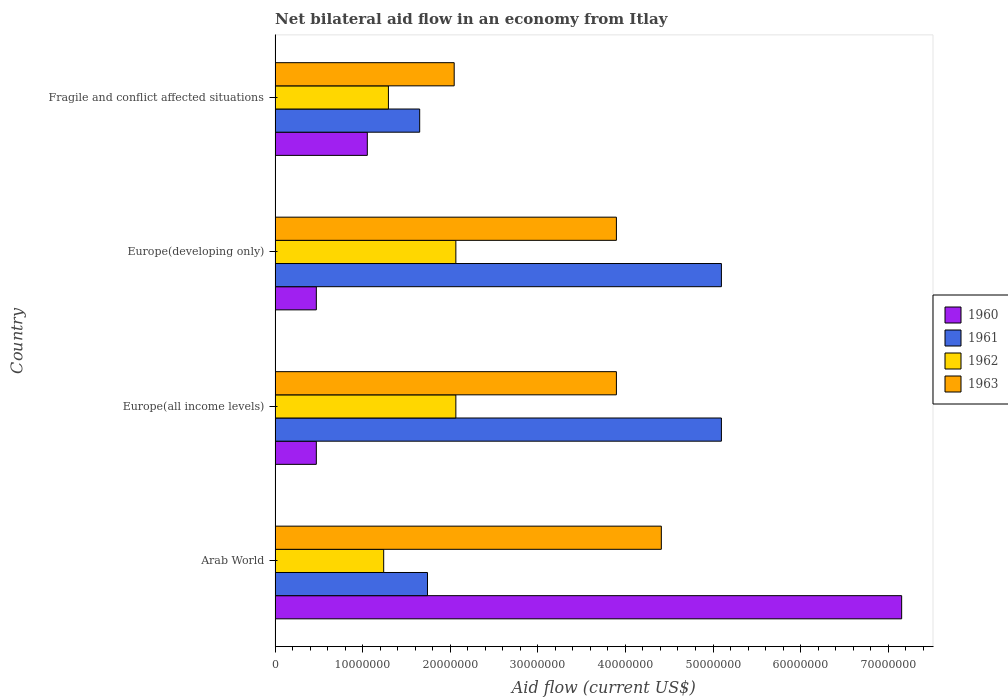How many bars are there on the 2nd tick from the top?
Your answer should be very brief. 4. What is the label of the 2nd group of bars from the top?
Provide a short and direct response. Europe(developing only). What is the net bilateral aid flow in 1963 in Arab World?
Give a very brief answer. 4.41e+07. Across all countries, what is the maximum net bilateral aid flow in 1961?
Your answer should be compact. 5.10e+07. Across all countries, what is the minimum net bilateral aid flow in 1962?
Offer a very short reply. 1.24e+07. In which country was the net bilateral aid flow in 1961 maximum?
Offer a terse response. Europe(all income levels). In which country was the net bilateral aid flow in 1962 minimum?
Offer a very short reply. Arab World. What is the total net bilateral aid flow in 1960 in the graph?
Your answer should be very brief. 9.15e+07. What is the difference between the net bilateral aid flow in 1962 in Arab World and that in Fragile and conflict affected situations?
Your answer should be compact. -5.40e+05. What is the difference between the net bilateral aid flow in 1960 in Arab World and the net bilateral aid flow in 1963 in Europe(all income levels)?
Your response must be concise. 3.26e+07. What is the average net bilateral aid flow in 1963 per country?
Your answer should be very brief. 3.56e+07. What is the difference between the net bilateral aid flow in 1962 and net bilateral aid flow in 1960 in Fragile and conflict affected situations?
Offer a very short reply. 2.41e+06. What is the ratio of the net bilateral aid flow in 1960 in Europe(developing only) to that in Fragile and conflict affected situations?
Your answer should be compact. 0.45. Is the net bilateral aid flow in 1961 in Arab World less than that in Europe(all income levels)?
Make the answer very short. Yes. What is the difference between the highest and the second highest net bilateral aid flow in 1960?
Keep it short and to the point. 6.10e+07. What is the difference between the highest and the lowest net bilateral aid flow in 1962?
Provide a short and direct response. 8.24e+06. In how many countries, is the net bilateral aid flow in 1961 greater than the average net bilateral aid flow in 1961 taken over all countries?
Ensure brevity in your answer.  2. What does the 4th bar from the top in Fragile and conflict affected situations represents?
Your answer should be compact. 1960. Are all the bars in the graph horizontal?
Keep it short and to the point. Yes. What is the difference between two consecutive major ticks on the X-axis?
Your response must be concise. 1.00e+07. Are the values on the major ticks of X-axis written in scientific E-notation?
Your response must be concise. No. Does the graph contain grids?
Your answer should be compact. No. Where does the legend appear in the graph?
Make the answer very short. Center right. How are the legend labels stacked?
Provide a succinct answer. Vertical. What is the title of the graph?
Give a very brief answer. Net bilateral aid flow in an economy from Itlay. Does "1995" appear as one of the legend labels in the graph?
Your answer should be very brief. No. What is the label or title of the Y-axis?
Your response must be concise. Country. What is the Aid flow (current US$) of 1960 in Arab World?
Your answer should be very brief. 7.15e+07. What is the Aid flow (current US$) in 1961 in Arab World?
Offer a very short reply. 1.74e+07. What is the Aid flow (current US$) in 1962 in Arab World?
Your answer should be very brief. 1.24e+07. What is the Aid flow (current US$) of 1963 in Arab World?
Offer a terse response. 4.41e+07. What is the Aid flow (current US$) in 1960 in Europe(all income levels)?
Offer a terse response. 4.71e+06. What is the Aid flow (current US$) of 1961 in Europe(all income levels)?
Make the answer very short. 5.10e+07. What is the Aid flow (current US$) of 1962 in Europe(all income levels)?
Your answer should be compact. 2.06e+07. What is the Aid flow (current US$) of 1963 in Europe(all income levels)?
Offer a very short reply. 3.90e+07. What is the Aid flow (current US$) of 1960 in Europe(developing only)?
Keep it short and to the point. 4.71e+06. What is the Aid flow (current US$) of 1961 in Europe(developing only)?
Keep it short and to the point. 5.10e+07. What is the Aid flow (current US$) in 1962 in Europe(developing only)?
Make the answer very short. 2.06e+07. What is the Aid flow (current US$) in 1963 in Europe(developing only)?
Make the answer very short. 3.90e+07. What is the Aid flow (current US$) of 1960 in Fragile and conflict affected situations?
Ensure brevity in your answer.  1.05e+07. What is the Aid flow (current US$) of 1961 in Fragile and conflict affected situations?
Give a very brief answer. 1.65e+07. What is the Aid flow (current US$) in 1962 in Fragile and conflict affected situations?
Offer a terse response. 1.29e+07. What is the Aid flow (current US$) in 1963 in Fragile and conflict affected situations?
Your answer should be compact. 2.04e+07. Across all countries, what is the maximum Aid flow (current US$) of 1960?
Your response must be concise. 7.15e+07. Across all countries, what is the maximum Aid flow (current US$) in 1961?
Provide a short and direct response. 5.10e+07. Across all countries, what is the maximum Aid flow (current US$) in 1962?
Ensure brevity in your answer.  2.06e+07. Across all countries, what is the maximum Aid flow (current US$) in 1963?
Your answer should be compact. 4.41e+07. Across all countries, what is the minimum Aid flow (current US$) in 1960?
Provide a short and direct response. 4.71e+06. Across all countries, what is the minimum Aid flow (current US$) of 1961?
Give a very brief answer. 1.65e+07. Across all countries, what is the minimum Aid flow (current US$) in 1962?
Offer a terse response. 1.24e+07. Across all countries, what is the minimum Aid flow (current US$) of 1963?
Give a very brief answer. 2.04e+07. What is the total Aid flow (current US$) in 1960 in the graph?
Provide a short and direct response. 9.15e+07. What is the total Aid flow (current US$) of 1961 in the graph?
Give a very brief answer. 1.36e+08. What is the total Aid flow (current US$) of 1962 in the graph?
Make the answer very short. 6.66e+07. What is the total Aid flow (current US$) of 1963 in the graph?
Keep it short and to the point. 1.42e+08. What is the difference between the Aid flow (current US$) in 1960 in Arab World and that in Europe(all income levels)?
Your answer should be compact. 6.68e+07. What is the difference between the Aid flow (current US$) of 1961 in Arab World and that in Europe(all income levels)?
Keep it short and to the point. -3.36e+07. What is the difference between the Aid flow (current US$) in 1962 in Arab World and that in Europe(all income levels)?
Keep it short and to the point. -8.24e+06. What is the difference between the Aid flow (current US$) of 1963 in Arab World and that in Europe(all income levels)?
Keep it short and to the point. 5.13e+06. What is the difference between the Aid flow (current US$) of 1960 in Arab World and that in Europe(developing only)?
Keep it short and to the point. 6.68e+07. What is the difference between the Aid flow (current US$) in 1961 in Arab World and that in Europe(developing only)?
Provide a succinct answer. -3.36e+07. What is the difference between the Aid flow (current US$) of 1962 in Arab World and that in Europe(developing only)?
Your answer should be very brief. -8.24e+06. What is the difference between the Aid flow (current US$) in 1963 in Arab World and that in Europe(developing only)?
Offer a terse response. 5.13e+06. What is the difference between the Aid flow (current US$) of 1960 in Arab World and that in Fragile and conflict affected situations?
Offer a terse response. 6.10e+07. What is the difference between the Aid flow (current US$) in 1961 in Arab World and that in Fragile and conflict affected situations?
Your answer should be very brief. 8.90e+05. What is the difference between the Aid flow (current US$) of 1962 in Arab World and that in Fragile and conflict affected situations?
Ensure brevity in your answer.  -5.40e+05. What is the difference between the Aid flow (current US$) of 1963 in Arab World and that in Fragile and conflict affected situations?
Your response must be concise. 2.36e+07. What is the difference between the Aid flow (current US$) in 1960 in Europe(all income levels) and that in Europe(developing only)?
Offer a terse response. 0. What is the difference between the Aid flow (current US$) of 1961 in Europe(all income levels) and that in Europe(developing only)?
Keep it short and to the point. 0. What is the difference between the Aid flow (current US$) of 1962 in Europe(all income levels) and that in Europe(developing only)?
Keep it short and to the point. 0. What is the difference between the Aid flow (current US$) of 1963 in Europe(all income levels) and that in Europe(developing only)?
Offer a very short reply. 0. What is the difference between the Aid flow (current US$) of 1960 in Europe(all income levels) and that in Fragile and conflict affected situations?
Your answer should be compact. -5.82e+06. What is the difference between the Aid flow (current US$) in 1961 in Europe(all income levels) and that in Fragile and conflict affected situations?
Provide a short and direct response. 3.44e+07. What is the difference between the Aid flow (current US$) in 1962 in Europe(all income levels) and that in Fragile and conflict affected situations?
Offer a very short reply. 7.70e+06. What is the difference between the Aid flow (current US$) in 1963 in Europe(all income levels) and that in Fragile and conflict affected situations?
Keep it short and to the point. 1.85e+07. What is the difference between the Aid flow (current US$) of 1960 in Europe(developing only) and that in Fragile and conflict affected situations?
Provide a succinct answer. -5.82e+06. What is the difference between the Aid flow (current US$) of 1961 in Europe(developing only) and that in Fragile and conflict affected situations?
Your response must be concise. 3.44e+07. What is the difference between the Aid flow (current US$) in 1962 in Europe(developing only) and that in Fragile and conflict affected situations?
Offer a very short reply. 7.70e+06. What is the difference between the Aid flow (current US$) of 1963 in Europe(developing only) and that in Fragile and conflict affected situations?
Ensure brevity in your answer.  1.85e+07. What is the difference between the Aid flow (current US$) of 1960 in Arab World and the Aid flow (current US$) of 1961 in Europe(all income levels)?
Offer a very short reply. 2.06e+07. What is the difference between the Aid flow (current US$) in 1960 in Arab World and the Aid flow (current US$) in 1962 in Europe(all income levels)?
Provide a succinct answer. 5.09e+07. What is the difference between the Aid flow (current US$) of 1960 in Arab World and the Aid flow (current US$) of 1963 in Europe(all income levels)?
Keep it short and to the point. 3.26e+07. What is the difference between the Aid flow (current US$) of 1961 in Arab World and the Aid flow (current US$) of 1962 in Europe(all income levels)?
Make the answer very short. -3.24e+06. What is the difference between the Aid flow (current US$) of 1961 in Arab World and the Aid flow (current US$) of 1963 in Europe(all income levels)?
Your answer should be very brief. -2.16e+07. What is the difference between the Aid flow (current US$) of 1962 in Arab World and the Aid flow (current US$) of 1963 in Europe(all income levels)?
Your response must be concise. -2.66e+07. What is the difference between the Aid flow (current US$) in 1960 in Arab World and the Aid flow (current US$) in 1961 in Europe(developing only)?
Keep it short and to the point. 2.06e+07. What is the difference between the Aid flow (current US$) in 1960 in Arab World and the Aid flow (current US$) in 1962 in Europe(developing only)?
Give a very brief answer. 5.09e+07. What is the difference between the Aid flow (current US$) of 1960 in Arab World and the Aid flow (current US$) of 1963 in Europe(developing only)?
Offer a very short reply. 3.26e+07. What is the difference between the Aid flow (current US$) of 1961 in Arab World and the Aid flow (current US$) of 1962 in Europe(developing only)?
Provide a short and direct response. -3.24e+06. What is the difference between the Aid flow (current US$) of 1961 in Arab World and the Aid flow (current US$) of 1963 in Europe(developing only)?
Ensure brevity in your answer.  -2.16e+07. What is the difference between the Aid flow (current US$) in 1962 in Arab World and the Aid flow (current US$) in 1963 in Europe(developing only)?
Your response must be concise. -2.66e+07. What is the difference between the Aid flow (current US$) of 1960 in Arab World and the Aid flow (current US$) of 1961 in Fragile and conflict affected situations?
Offer a terse response. 5.50e+07. What is the difference between the Aid flow (current US$) in 1960 in Arab World and the Aid flow (current US$) in 1962 in Fragile and conflict affected situations?
Ensure brevity in your answer.  5.86e+07. What is the difference between the Aid flow (current US$) in 1960 in Arab World and the Aid flow (current US$) in 1963 in Fragile and conflict affected situations?
Ensure brevity in your answer.  5.11e+07. What is the difference between the Aid flow (current US$) in 1961 in Arab World and the Aid flow (current US$) in 1962 in Fragile and conflict affected situations?
Ensure brevity in your answer.  4.46e+06. What is the difference between the Aid flow (current US$) of 1961 in Arab World and the Aid flow (current US$) of 1963 in Fragile and conflict affected situations?
Offer a very short reply. -3.05e+06. What is the difference between the Aid flow (current US$) in 1962 in Arab World and the Aid flow (current US$) in 1963 in Fragile and conflict affected situations?
Offer a terse response. -8.05e+06. What is the difference between the Aid flow (current US$) of 1960 in Europe(all income levels) and the Aid flow (current US$) of 1961 in Europe(developing only)?
Make the answer very short. -4.62e+07. What is the difference between the Aid flow (current US$) of 1960 in Europe(all income levels) and the Aid flow (current US$) of 1962 in Europe(developing only)?
Ensure brevity in your answer.  -1.59e+07. What is the difference between the Aid flow (current US$) of 1960 in Europe(all income levels) and the Aid flow (current US$) of 1963 in Europe(developing only)?
Keep it short and to the point. -3.43e+07. What is the difference between the Aid flow (current US$) of 1961 in Europe(all income levels) and the Aid flow (current US$) of 1962 in Europe(developing only)?
Your answer should be compact. 3.03e+07. What is the difference between the Aid flow (current US$) in 1961 in Europe(all income levels) and the Aid flow (current US$) in 1963 in Europe(developing only)?
Keep it short and to the point. 1.20e+07. What is the difference between the Aid flow (current US$) in 1962 in Europe(all income levels) and the Aid flow (current US$) in 1963 in Europe(developing only)?
Offer a very short reply. -1.83e+07. What is the difference between the Aid flow (current US$) in 1960 in Europe(all income levels) and the Aid flow (current US$) in 1961 in Fragile and conflict affected situations?
Provide a short and direct response. -1.18e+07. What is the difference between the Aid flow (current US$) of 1960 in Europe(all income levels) and the Aid flow (current US$) of 1962 in Fragile and conflict affected situations?
Give a very brief answer. -8.23e+06. What is the difference between the Aid flow (current US$) in 1960 in Europe(all income levels) and the Aid flow (current US$) in 1963 in Fragile and conflict affected situations?
Offer a very short reply. -1.57e+07. What is the difference between the Aid flow (current US$) of 1961 in Europe(all income levels) and the Aid flow (current US$) of 1962 in Fragile and conflict affected situations?
Keep it short and to the point. 3.80e+07. What is the difference between the Aid flow (current US$) of 1961 in Europe(all income levels) and the Aid flow (current US$) of 1963 in Fragile and conflict affected situations?
Offer a terse response. 3.05e+07. What is the difference between the Aid flow (current US$) of 1962 in Europe(all income levels) and the Aid flow (current US$) of 1963 in Fragile and conflict affected situations?
Ensure brevity in your answer.  1.90e+05. What is the difference between the Aid flow (current US$) of 1960 in Europe(developing only) and the Aid flow (current US$) of 1961 in Fragile and conflict affected situations?
Your answer should be compact. -1.18e+07. What is the difference between the Aid flow (current US$) in 1960 in Europe(developing only) and the Aid flow (current US$) in 1962 in Fragile and conflict affected situations?
Ensure brevity in your answer.  -8.23e+06. What is the difference between the Aid flow (current US$) of 1960 in Europe(developing only) and the Aid flow (current US$) of 1963 in Fragile and conflict affected situations?
Keep it short and to the point. -1.57e+07. What is the difference between the Aid flow (current US$) in 1961 in Europe(developing only) and the Aid flow (current US$) in 1962 in Fragile and conflict affected situations?
Your response must be concise. 3.80e+07. What is the difference between the Aid flow (current US$) in 1961 in Europe(developing only) and the Aid flow (current US$) in 1963 in Fragile and conflict affected situations?
Give a very brief answer. 3.05e+07. What is the difference between the Aid flow (current US$) in 1962 in Europe(developing only) and the Aid flow (current US$) in 1963 in Fragile and conflict affected situations?
Keep it short and to the point. 1.90e+05. What is the average Aid flow (current US$) of 1960 per country?
Ensure brevity in your answer.  2.29e+07. What is the average Aid flow (current US$) in 1961 per country?
Your answer should be compact. 3.40e+07. What is the average Aid flow (current US$) of 1962 per country?
Your answer should be very brief. 1.67e+07. What is the average Aid flow (current US$) in 1963 per country?
Your answer should be very brief. 3.56e+07. What is the difference between the Aid flow (current US$) in 1960 and Aid flow (current US$) in 1961 in Arab World?
Provide a succinct answer. 5.41e+07. What is the difference between the Aid flow (current US$) of 1960 and Aid flow (current US$) of 1962 in Arab World?
Give a very brief answer. 5.91e+07. What is the difference between the Aid flow (current US$) of 1960 and Aid flow (current US$) of 1963 in Arab World?
Offer a very short reply. 2.74e+07. What is the difference between the Aid flow (current US$) in 1961 and Aid flow (current US$) in 1962 in Arab World?
Keep it short and to the point. 5.00e+06. What is the difference between the Aid flow (current US$) of 1961 and Aid flow (current US$) of 1963 in Arab World?
Your answer should be very brief. -2.67e+07. What is the difference between the Aid flow (current US$) of 1962 and Aid flow (current US$) of 1963 in Arab World?
Your answer should be very brief. -3.17e+07. What is the difference between the Aid flow (current US$) in 1960 and Aid flow (current US$) in 1961 in Europe(all income levels)?
Provide a succinct answer. -4.62e+07. What is the difference between the Aid flow (current US$) in 1960 and Aid flow (current US$) in 1962 in Europe(all income levels)?
Your answer should be compact. -1.59e+07. What is the difference between the Aid flow (current US$) of 1960 and Aid flow (current US$) of 1963 in Europe(all income levels)?
Ensure brevity in your answer.  -3.43e+07. What is the difference between the Aid flow (current US$) in 1961 and Aid flow (current US$) in 1962 in Europe(all income levels)?
Provide a short and direct response. 3.03e+07. What is the difference between the Aid flow (current US$) in 1961 and Aid flow (current US$) in 1963 in Europe(all income levels)?
Provide a short and direct response. 1.20e+07. What is the difference between the Aid flow (current US$) of 1962 and Aid flow (current US$) of 1963 in Europe(all income levels)?
Make the answer very short. -1.83e+07. What is the difference between the Aid flow (current US$) of 1960 and Aid flow (current US$) of 1961 in Europe(developing only)?
Give a very brief answer. -4.62e+07. What is the difference between the Aid flow (current US$) in 1960 and Aid flow (current US$) in 1962 in Europe(developing only)?
Keep it short and to the point. -1.59e+07. What is the difference between the Aid flow (current US$) in 1960 and Aid flow (current US$) in 1963 in Europe(developing only)?
Provide a short and direct response. -3.43e+07. What is the difference between the Aid flow (current US$) in 1961 and Aid flow (current US$) in 1962 in Europe(developing only)?
Your response must be concise. 3.03e+07. What is the difference between the Aid flow (current US$) of 1961 and Aid flow (current US$) of 1963 in Europe(developing only)?
Keep it short and to the point. 1.20e+07. What is the difference between the Aid flow (current US$) in 1962 and Aid flow (current US$) in 1963 in Europe(developing only)?
Keep it short and to the point. -1.83e+07. What is the difference between the Aid flow (current US$) of 1960 and Aid flow (current US$) of 1961 in Fragile and conflict affected situations?
Offer a terse response. -5.98e+06. What is the difference between the Aid flow (current US$) of 1960 and Aid flow (current US$) of 1962 in Fragile and conflict affected situations?
Offer a terse response. -2.41e+06. What is the difference between the Aid flow (current US$) of 1960 and Aid flow (current US$) of 1963 in Fragile and conflict affected situations?
Keep it short and to the point. -9.92e+06. What is the difference between the Aid flow (current US$) in 1961 and Aid flow (current US$) in 1962 in Fragile and conflict affected situations?
Give a very brief answer. 3.57e+06. What is the difference between the Aid flow (current US$) of 1961 and Aid flow (current US$) of 1963 in Fragile and conflict affected situations?
Offer a very short reply. -3.94e+06. What is the difference between the Aid flow (current US$) in 1962 and Aid flow (current US$) in 1963 in Fragile and conflict affected situations?
Ensure brevity in your answer.  -7.51e+06. What is the ratio of the Aid flow (current US$) of 1960 in Arab World to that in Europe(all income levels)?
Provide a succinct answer. 15.19. What is the ratio of the Aid flow (current US$) in 1961 in Arab World to that in Europe(all income levels)?
Make the answer very short. 0.34. What is the ratio of the Aid flow (current US$) in 1962 in Arab World to that in Europe(all income levels)?
Your answer should be compact. 0.6. What is the ratio of the Aid flow (current US$) of 1963 in Arab World to that in Europe(all income levels)?
Offer a very short reply. 1.13. What is the ratio of the Aid flow (current US$) in 1960 in Arab World to that in Europe(developing only)?
Offer a terse response. 15.19. What is the ratio of the Aid flow (current US$) in 1961 in Arab World to that in Europe(developing only)?
Your answer should be compact. 0.34. What is the ratio of the Aid flow (current US$) in 1962 in Arab World to that in Europe(developing only)?
Provide a succinct answer. 0.6. What is the ratio of the Aid flow (current US$) of 1963 in Arab World to that in Europe(developing only)?
Make the answer very short. 1.13. What is the ratio of the Aid flow (current US$) of 1960 in Arab World to that in Fragile and conflict affected situations?
Offer a very short reply. 6.79. What is the ratio of the Aid flow (current US$) in 1961 in Arab World to that in Fragile and conflict affected situations?
Your response must be concise. 1.05. What is the ratio of the Aid flow (current US$) in 1962 in Arab World to that in Fragile and conflict affected situations?
Ensure brevity in your answer.  0.96. What is the ratio of the Aid flow (current US$) in 1963 in Arab World to that in Fragile and conflict affected situations?
Your response must be concise. 2.16. What is the ratio of the Aid flow (current US$) of 1960 in Europe(all income levels) to that in Europe(developing only)?
Ensure brevity in your answer.  1. What is the ratio of the Aid flow (current US$) of 1963 in Europe(all income levels) to that in Europe(developing only)?
Keep it short and to the point. 1. What is the ratio of the Aid flow (current US$) in 1960 in Europe(all income levels) to that in Fragile and conflict affected situations?
Offer a terse response. 0.45. What is the ratio of the Aid flow (current US$) of 1961 in Europe(all income levels) to that in Fragile and conflict affected situations?
Give a very brief answer. 3.09. What is the ratio of the Aid flow (current US$) in 1962 in Europe(all income levels) to that in Fragile and conflict affected situations?
Keep it short and to the point. 1.6. What is the ratio of the Aid flow (current US$) in 1963 in Europe(all income levels) to that in Fragile and conflict affected situations?
Offer a very short reply. 1.91. What is the ratio of the Aid flow (current US$) in 1960 in Europe(developing only) to that in Fragile and conflict affected situations?
Your response must be concise. 0.45. What is the ratio of the Aid flow (current US$) of 1961 in Europe(developing only) to that in Fragile and conflict affected situations?
Your answer should be compact. 3.09. What is the ratio of the Aid flow (current US$) of 1962 in Europe(developing only) to that in Fragile and conflict affected situations?
Provide a succinct answer. 1.6. What is the ratio of the Aid flow (current US$) of 1963 in Europe(developing only) to that in Fragile and conflict affected situations?
Make the answer very short. 1.91. What is the difference between the highest and the second highest Aid flow (current US$) in 1960?
Your answer should be very brief. 6.10e+07. What is the difference between the highest and the second highest Aid flow (current US$) of 1961?
Give a very brief answer. 0. What is the difference between the highest and the second highest Aid flow (current US$) in 1962?
Your answer should be compact. 0. What is the difference between the highest and the second highest Aid flow (current US$) in 1963?
Provide a short and direct response. 5.13e+06. What is the difference between the highest and the lowest Aid flow (current US$) of 1960?
Make the answer very short. 6.68e+07. What is the difference between the highest and the lowest Aid flow (current US$) in 1961?
Make the answer very short. 3.44e+07. What is the difference between the highest and the lowest Aid flow (current US$) in 1962?
Keep it short and to the point. 8.24e+06. What is the difference between the highest and the lowest Aid flow (current US$) in 1963?
Provide a short and direct response. 2.36e+07. 